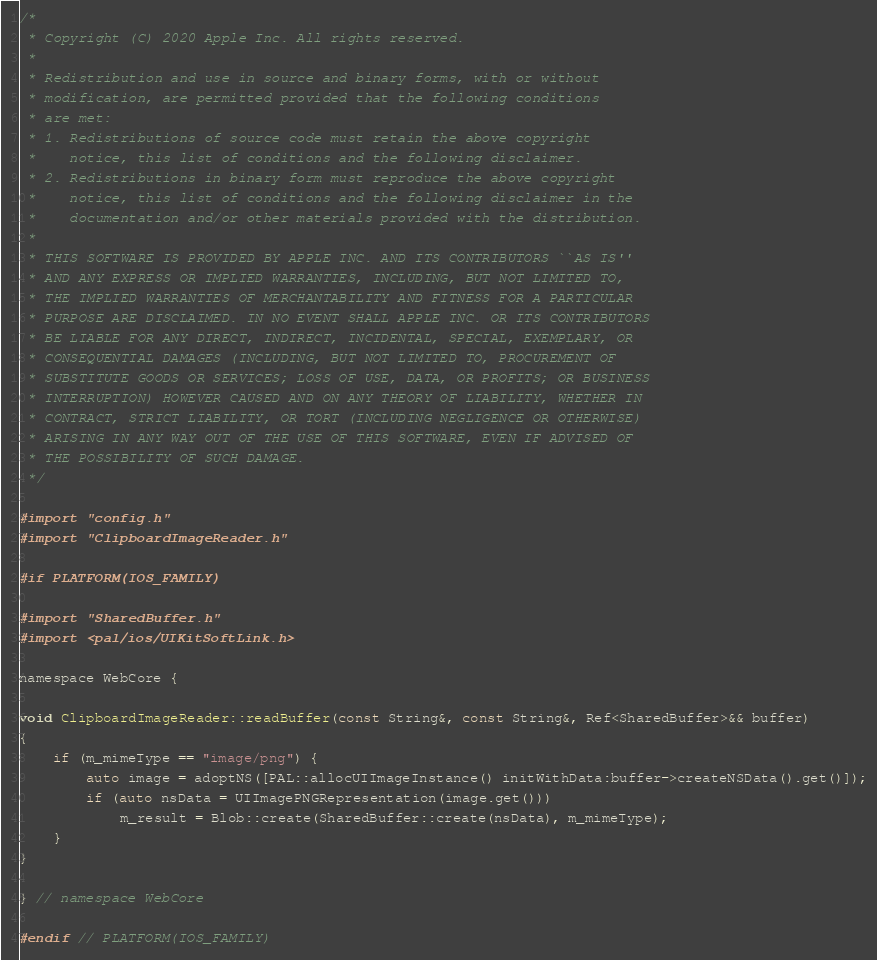Convert code to text. <code><loc_0><loc_0><loc_500><loc_500><_ObjectiveC_>/*
 * Copyright (C) 2020 Apple Inc. All rights reserved.
 *
 * Redistribution and use in source and binary forms, with or without
 * modification, are permitted provided that the following conditions
 * are met:
 * 1. Redistributions of source code must retain the above copyright
 *    notice, this list of conditions and the following disclaimer.
 * 2. Redistributions in binary form must reproduce the above copyright
 *    notice, this list of conditions and the following disclaimer in the
 *    documentation and/or other materials provided with the distribution.
 *
 * THIS SOFTWARE IS PROVIDED BY APPLE INC. AND ITS CONTRIBUTORS ``AS IS''
 * AND ANY EXPRESS OR IMPLIED WARRANTIES, INCLUDING, BUT NOT LIMITED TO,
 * THE IMPLIED WARRANTIES OF MERCHANTABILITY AND FITNESS FOR A PARTICULAR
 * PURPOSE ARE DISCLAIMED. IN NO EVENT SHALL APPLE INC. OR ITS CONTRIBUTORS
 * BE LIABLE FOR ANY DIRECT, INDIRECT, INCIDENTAL, SPECIAL, EXEMPLARY, OR
 * CONSEQUENTIAL DAMAGES (INCLUDING, BUT NOT LIMITED TO, PROCUREMENT OF
 * SUBSTITUTE GOODS OR SERVICES; LOSS OF USE, DATA, OR PROFITS; OR BUSINESS
 * INTERRUPTION) HOWEVER CAUSED AND ON ANY THEORY OF LIABILITY, WHETHER IN
 * CONTRACT, STRICT LIABILITY, OR TORT (INCLUDING NEGLIGENCE OR OTHERWISE)
 * ARISING IN ANY WAY OUT OF THE USE OF THIS SOFTWARE, EVEN IF ADVISED OF
 * THE POSSIBILITY OF SUCH DAMAGE.
 */

#import "config.h"
#import "ClipboardImageReader.h"

#if PLATFORM(IOS_FAMILY)

#import "SharedBuffer.h"
#import <pal/ios/UIKitSoftLink.h>

namespace WebCore {

void ClipboardImageReader::readBuffer(const String&, const String&, Ref<SharedBuffer>&& buffer)
{
    if (m_mimeType == "image/png") {
        auto image = adoptNS([PAL::allocUIImageInstance() initWithData:buffer->createNSData().get()]);
        if (auto nsData = UIImagePNGRepresentation(image.get()))
            m_result = Blob::create(SharedBuffer::create(nsData), m_mimeType);
    }
}

} // namespace WebCore

#endif // PLATFORM(IOS_FAMILY)
</code> 